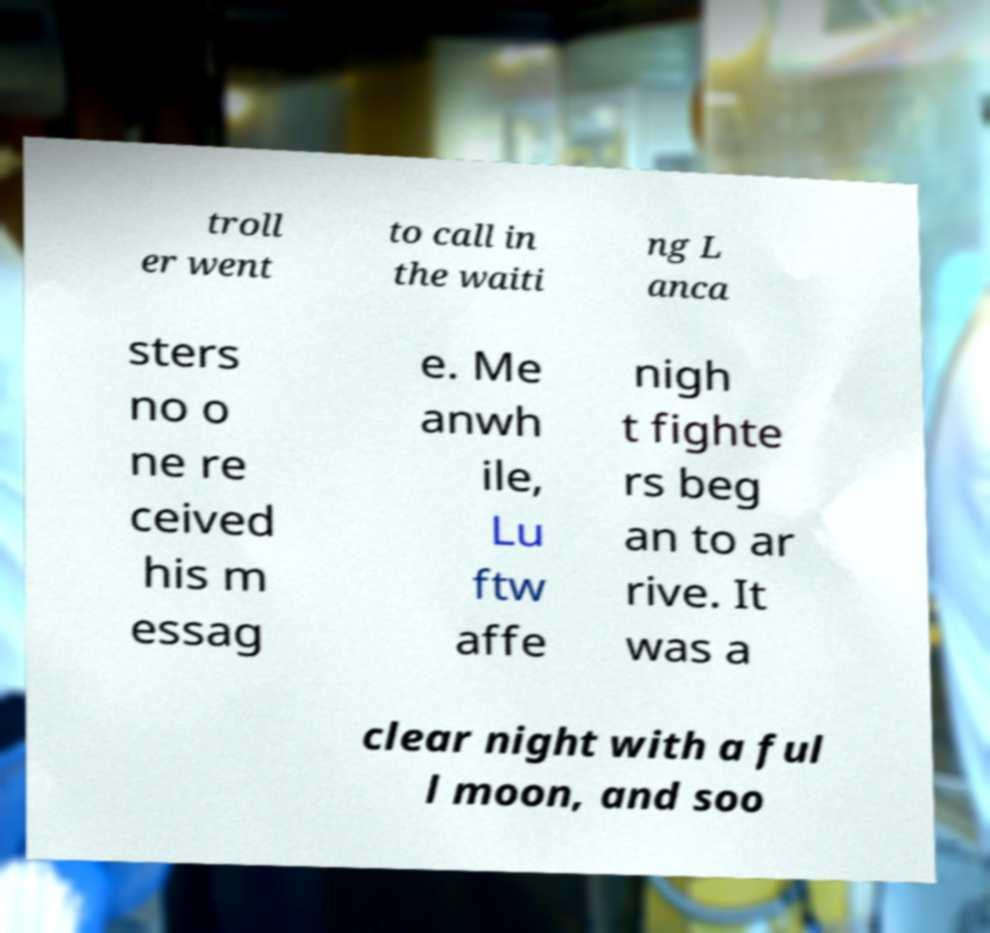I need the written content from this picture converted into text. Can you do that? troll er went to call in the waiti ng L anca sters no o ne re ceived his m essag e. Me anwh ile, Lu ftw affe nigh t fighte rs beg an to ar rive. It was a clear night with a ful l moon, and soo 